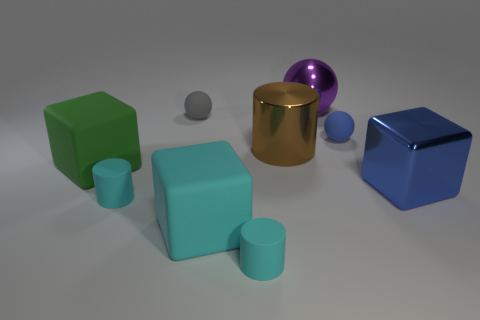There is a thing that is the same color as the metallic cube; what size is it?
Ensure brevity in your answer.  Small. Are there any other things that are the same size as the green object?
Give a very brief answer. Yes. There is a tiny cylinder on the right side of the matte object behind the tiny blue matte thing; what is it made of?
Provide a succinct answer. Rubber. How many metallic objects are green things or cyan cylinders?
Offer a very short reply. 0. What color is the other rubber thing that is the same shape as the gray thing?
Make the answer very short. Blue. What number of shiny cylinders are the same color as the big metal sphere?
Make the answer very short. 0. There is a matte thing on the right side of the brown object; are there any tiny cylinders behind it?
Your response must be concise. No. What number of large things are both right of the tiny gray sphere and in front of the gray ball?
Provide a short and direct response. 3. What number of objects are the same material as the blue sphere?
Your answer should be compact. 5. What size is the cube that is on the right side of the shiny thing left of the purple metal object?
Make the answer very short. Large. 